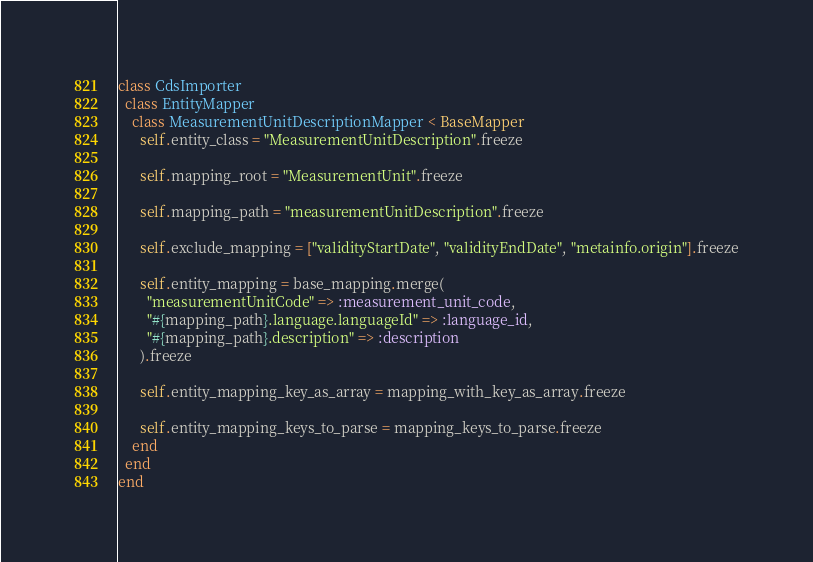Convert code to text. <code><loc_0><loc_0><loc_500><loc_500><_Ruby_>class CdsImporter
  class EntityMapper
    class MeasurementUnitDescriptionMapper < BaseMapper
      self.entity_class = "MeasurementUnitDescription".freeze

      self.mapping_root = "MeasurementUnit".freeze

      self.mapping_path = "measurementUnitDescription".freeze

      self.exclude_mapping = ["validityStartDate", "validityEndDate", "metainfo.origin"].freeze

      self.entity_mapping = base_mapping.merge(
        "measurementUnitCode" => :measurement_unit_code,
        "#{mapping_path}.language.languageId" => :language_id,
        "#{mapping_path}.description" => :description
      ).freeze

      self.entity_mapping_key_as_array = mapping_with_key_as_array.freeze

      self.entity_mapping_keys_to_parse = mapping_keys_to_parse.freeze
    end
  end
end
</code> 